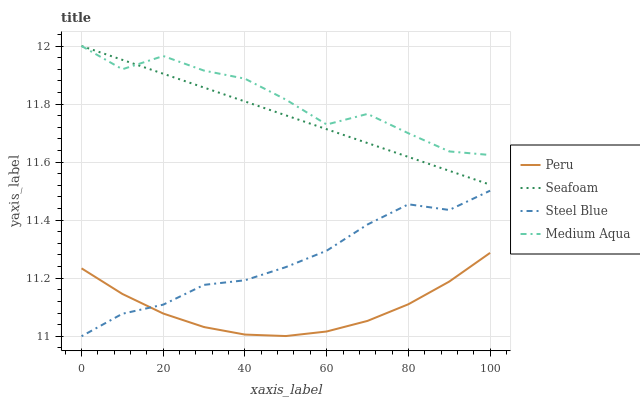Does Peru have the minimum area under the curve?
Answer yes or no. Yes. Does Medium Aqua have the maximum area under the curve?
Answer yes or no. Yes. Does Seafoam have the minimum area under the curve?
Answer yes or no. No. Does Seafoam have the maximum area under the curve?
Answer yes or no. No. Is Seafoam the smoothest?
Answer yes or no. Yes. Is Medium Aqua the roughest?
Answer yes or no. Yes. Is Peru the smoothest?
Answer yes or no. No. Is Peru the roughest?
Answer yes or no. No. Does Seafoam have the lowest value?
Answer yes or no. No. Does Seafoam have the highest value?
Answer yes or no. Yes. Does Peru have the highest value?
Answer yes or no. No. Is Peru less than Medium Aqua?
Answer yes or no. Yes. Is Medium Aqua greater than Steel Blue?
Answer yes or no. Yes. Does Steel Blue intersect Peru?
Answer yes or no. Yes. Is Steel Blue less than Peru?
Answer yes or no. No. Is Steel Blue greater than Peru?
Answer yes or no. No. Does Peru intersect Medium Aqua?
Answer yes or no. No. 